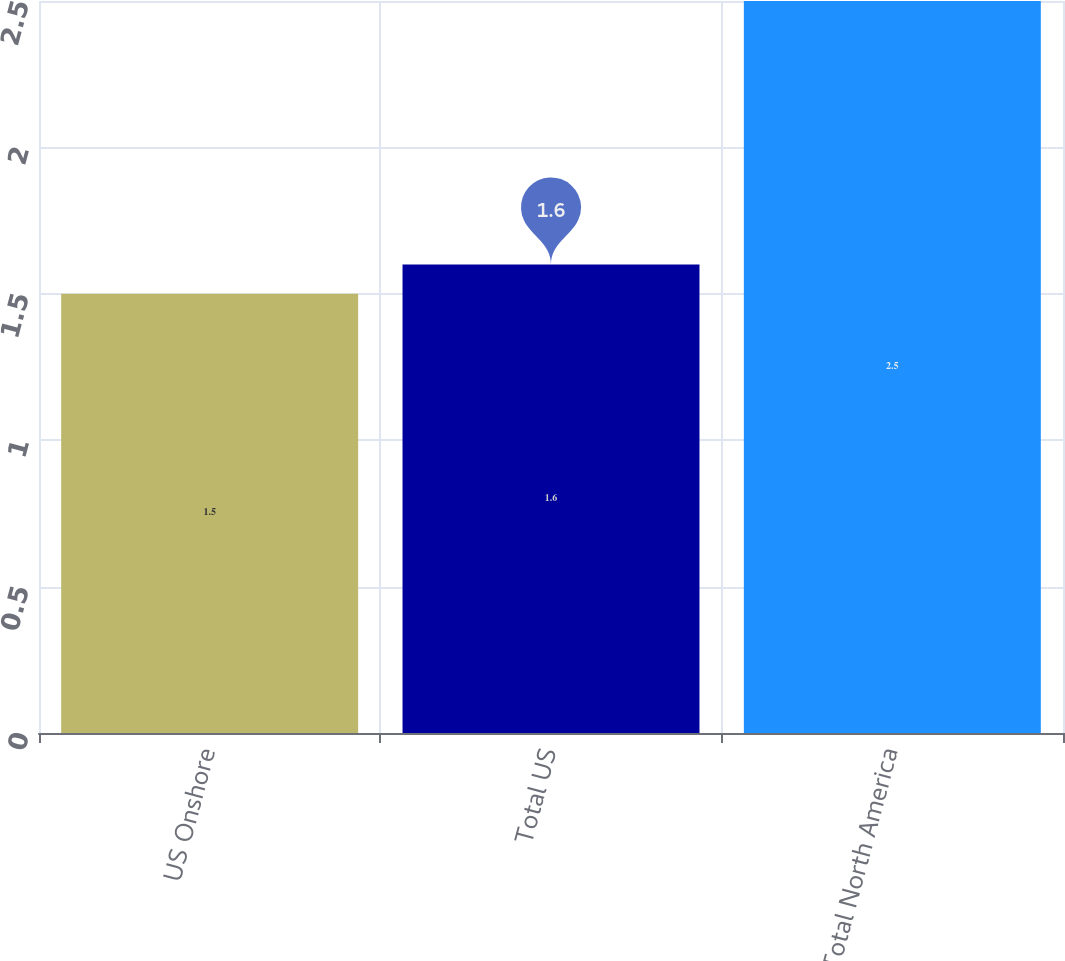Convert chart to OTSL. <chart><loc_0><loc_0><loc_500><loc_500><bar_chart><fcel>US Onshore<fcel>Total US<fcel>Total North America<nl><fcel>1.5<fcel>1.6<fcel>2.5<nl></chart> 